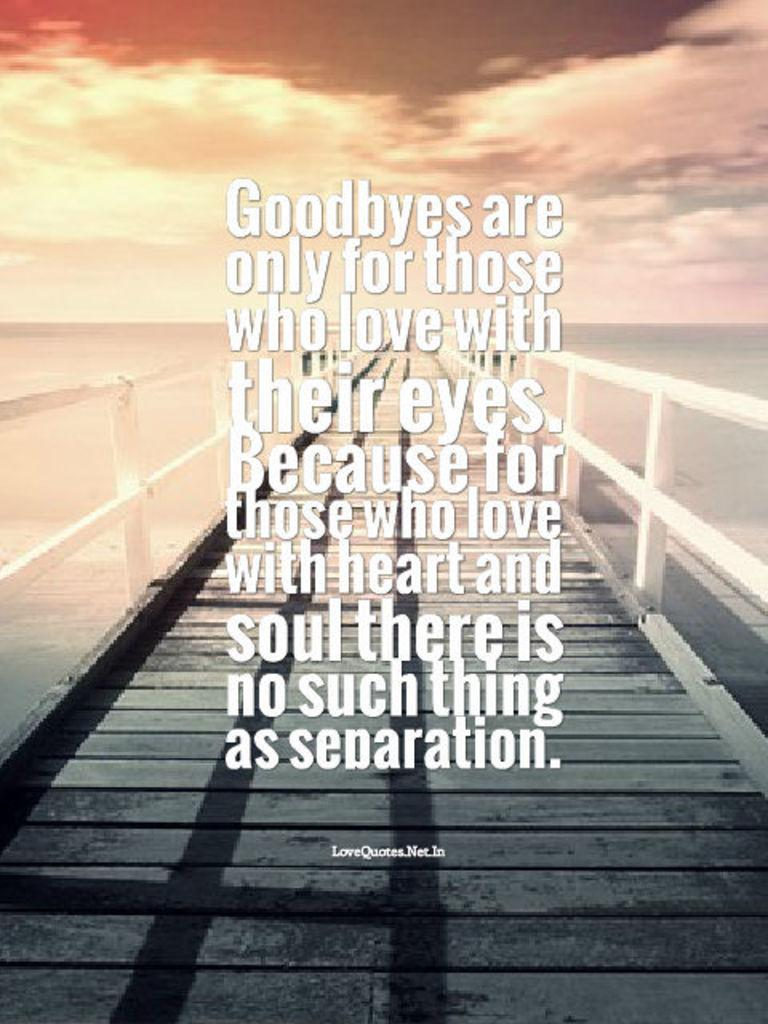<image>
Render a clear and concise summary of the photo. a poster with the main message being goodbyes are only for those who love 